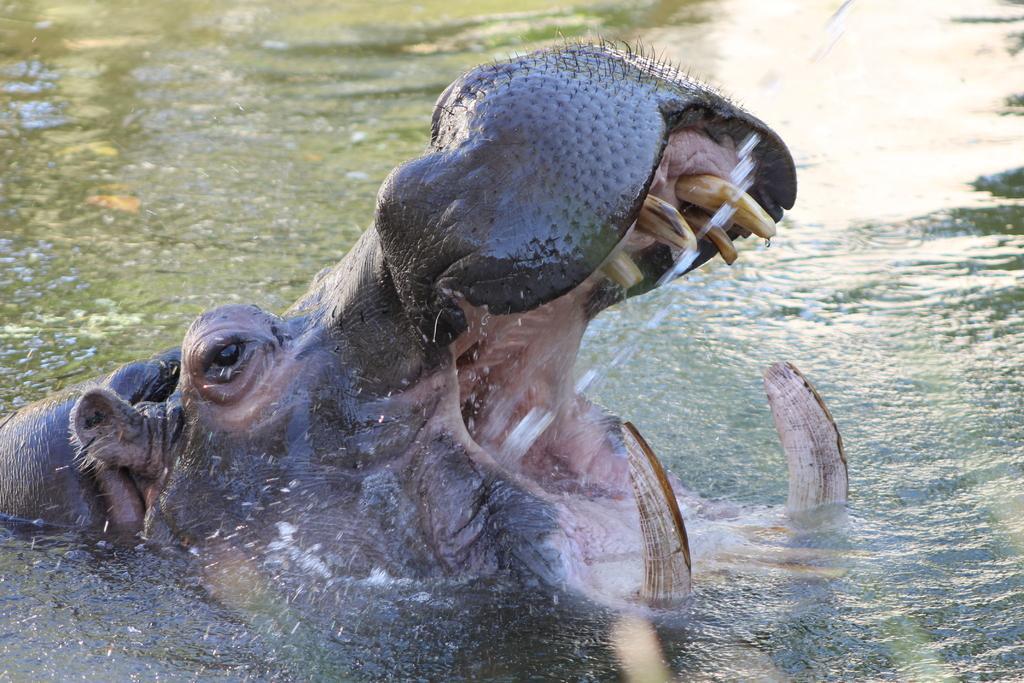In one or two sentences, can you explain what this image depicts? In the image we can see a hippopotamus in the water. This is a water. 